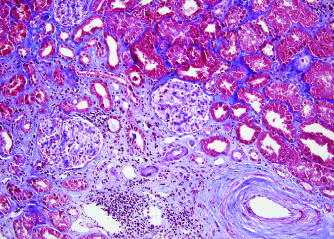does the blue area show fibrosis, contrasted with the normal kidney right in this trichrome stain?
Answer the question using a single word or phrase. Yes 